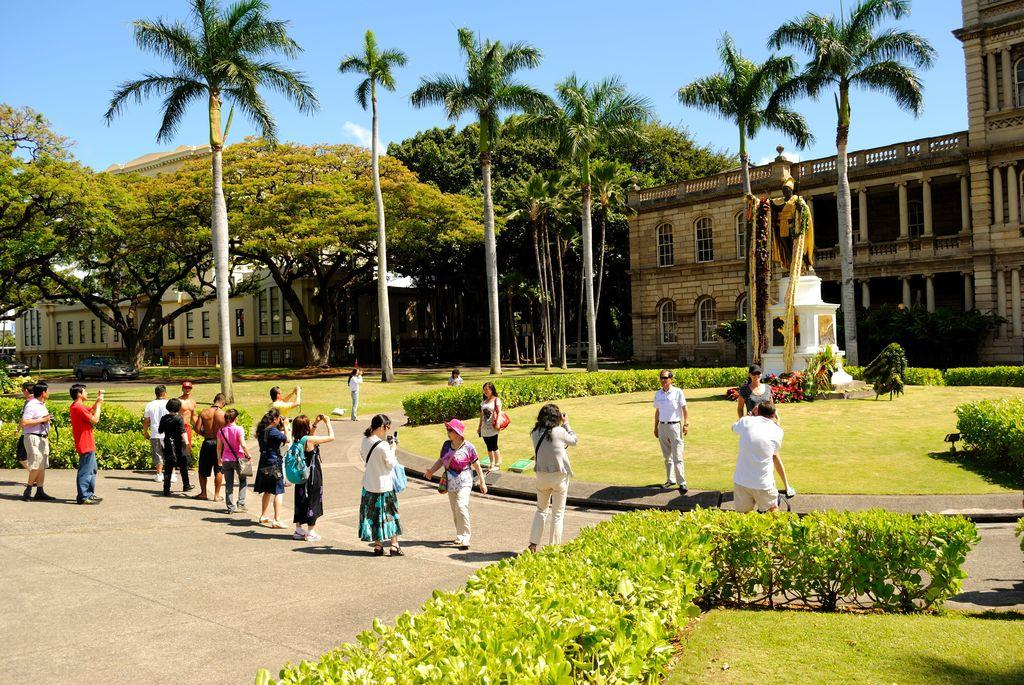What are the people in the image doing? The people are standing and clicking images of a statue. What is located in front of the people? The statue is in front of the people. What can be seen in the background of the image? There are buildings and trees in the background of the image. Are there any plants visible in the image? Yes, there are bushes in the image. What type of bells can be heard ringing in the image? There are no bells present in the image, and therefore no sound can be heard. 